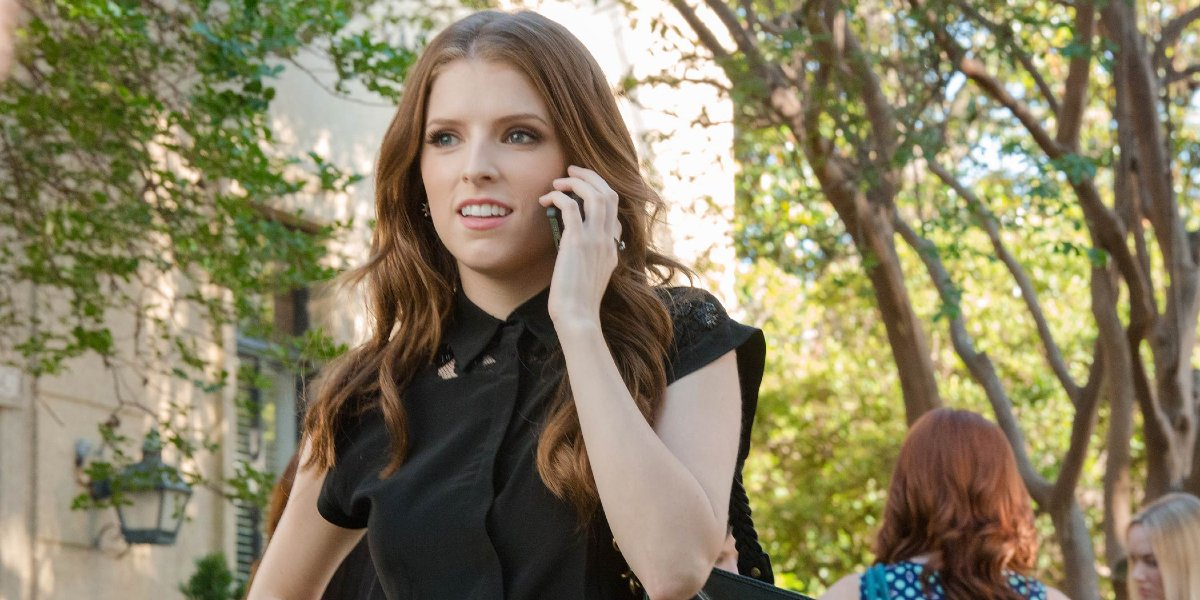If this image were part of a movie, what kind of scene would it be? If this image were part of a movie, it might be a poignant scene where the character, feeling conflicted, takes a walk to clear her mind. The serene setting contrasts with her inner turmoil, highlighting a pivotal moment where she's handling a personal or professional crisis over the phone. The scene could build up to a significant decision or a revelation she has during this walk, captured beautifully by the shifting light and shadows of the tree-lined street. Describe the emotion conveyed in the scene if run through a cinematic lens. Through a cinematic lens, the emotion conveyed in this scene is a mix of tension, reflection, and a touch of melancholy. The gentle rustling of leaves and the soft, filtered light evoke a sense of calm, yet the character’s expression and body language hint at and underscore a deeper concern. This juxtaposition makes the moment richer and more layered, suggesting that even in serene settings, personal struggles persist and quietly unfold. If you were to add a soundtrack to this scene, what kind of music would you choose? For this scene, a soft, instrumental score with a blend of piano and strings would be ideal. Something gentle yet haunting, perhaps with a slowly blooming melody to echo the natural surroundings and the character's introspection. The music should subtly enhance the emotion, making the viewer feel the gravity of her conversation without overpowering the delicate ambiance of the setting. 